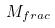<formula> <loc_0><loc_0><loc_500><loc_500>M _ { f r a c }</formula> 